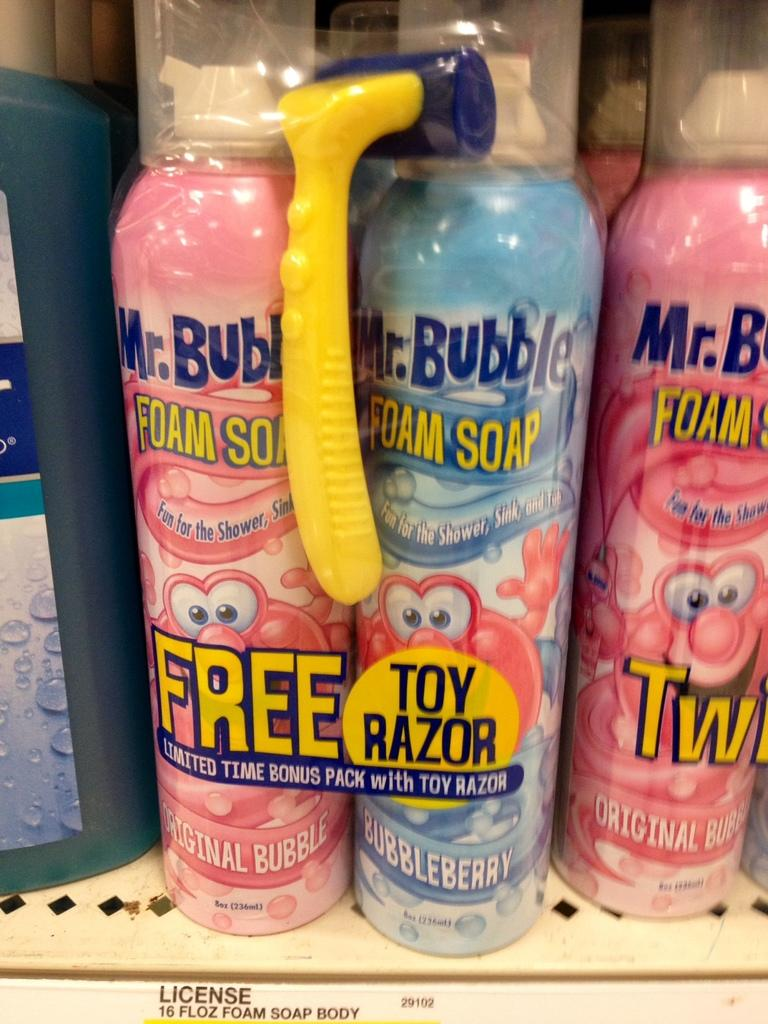<image>
Provide a brief description of the given image. A bundle of Mr. Bubble foam soap with a free toy razor. 